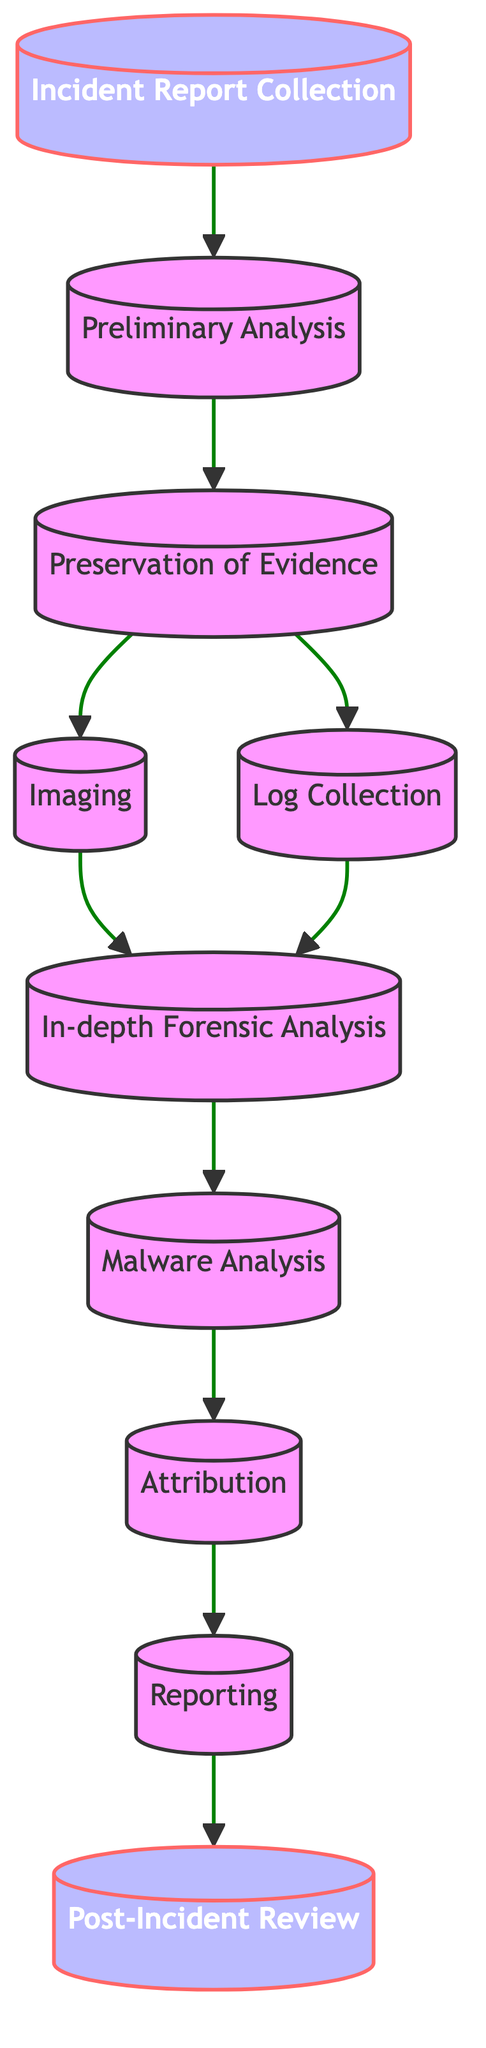What is the first step in the workflow? The first step is indicated by the starting node in the directed graph, which is "Incident Report Collection." This node does not have any incoming edges and leads directly to the next step.
Answer: Incident Report Collection How many nodes are in this diagram? To determine the number of nodes, we count each unique step represented in the diagram. There are ten distinct nodes.
Answer: 10 What happens after "Preservation of Evidence"? The "Preservation of Evidence" node has two outgoing edges; it leads to both "Imaging" and "Log Collection," showing that both processes can occur simultaneously.
Answer: Imaging and Log Collection What is the last step in the workflow? The last step is the final node in the graph, which can be identified by the absence of outgoing edges. The last step is "Post-Incident Review."
Answer: Post-Incident Review How many paths lead from "Preservation of Evidence"? There are two paths that diverge from the "Preservation of Evidence" node: one leads to "Imaging" and the other to "Log Collection." These paths represent parallel processes that can occur at this stage of the workflow.
Answer: 2 Which step directly follows "Malware Analysis"? The diagram indicates a sequential flow where "Malware Analysis" has a direct edge leading to "Attribution." Thus, "Attribution" is the immediate next step.
Answer: Attribution What is the relationship between "Reporting" and "Attribution"? In the directed graph, "Reporting" comes after "Attribution," indicating that the findings from "Attribution" are compiled into the "Reporting" step. The relationship is one of sequential dependency.
Answer: Sequential Which steps occur after the "In-depth Forensic Analysis"? After "In-depth Forensic Analysis," the next step is "Malware Analysis." This denotes a direct progression from examining the data to analyzing potential malware identified in the previous step.
Answer: Malware Analysis What type of analysis is conducted immediately after the collection of logs? After the "Log Collection" phase, the workflow indicates that the next analysis performed is "In-depth Forensic Analysis," indicating a transition from data collection to detailed examination.
Answer: In-depth Forensic Analysis 